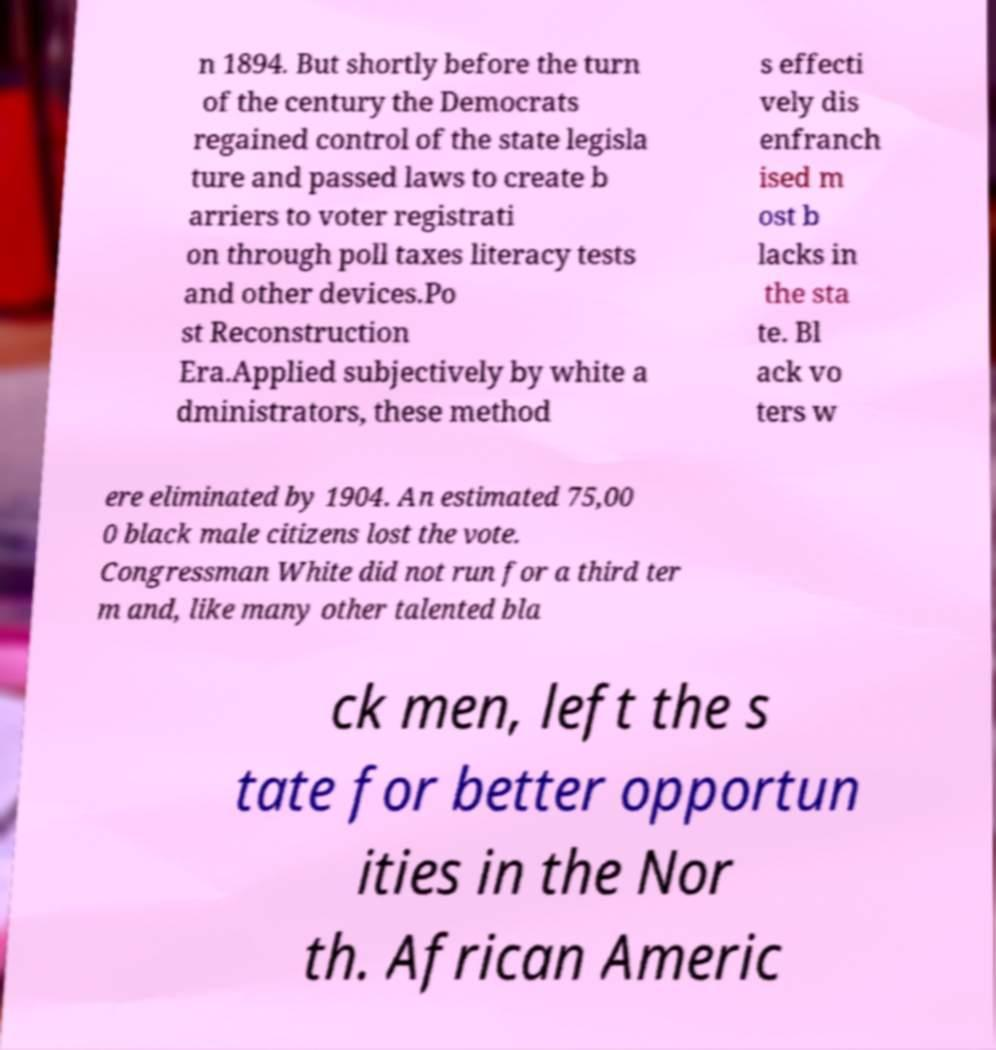There's text embedded in this image that I need extracted. Can you transcribe it verbatim? n 1894. But shortly before the turn of the century the Democrats regained control of the state legisla ture and passed laws to create b arriers to voter registrati on through poll taxes literacy tests and other devices.Po st Reconstruction Era.Applied subjectively by white a dministrators, these method s effecti vely dis enfranch ised m ost b lacks in the sta te. Bl ack vo ters w ere eliminated by 1904. An estimated 75,00 0 black male citizens lost the vote. Congressman White did not run for a third ter m and, like many other talented bla ck men, left the s tate for better opportun ities in the Nor th. African Americ 